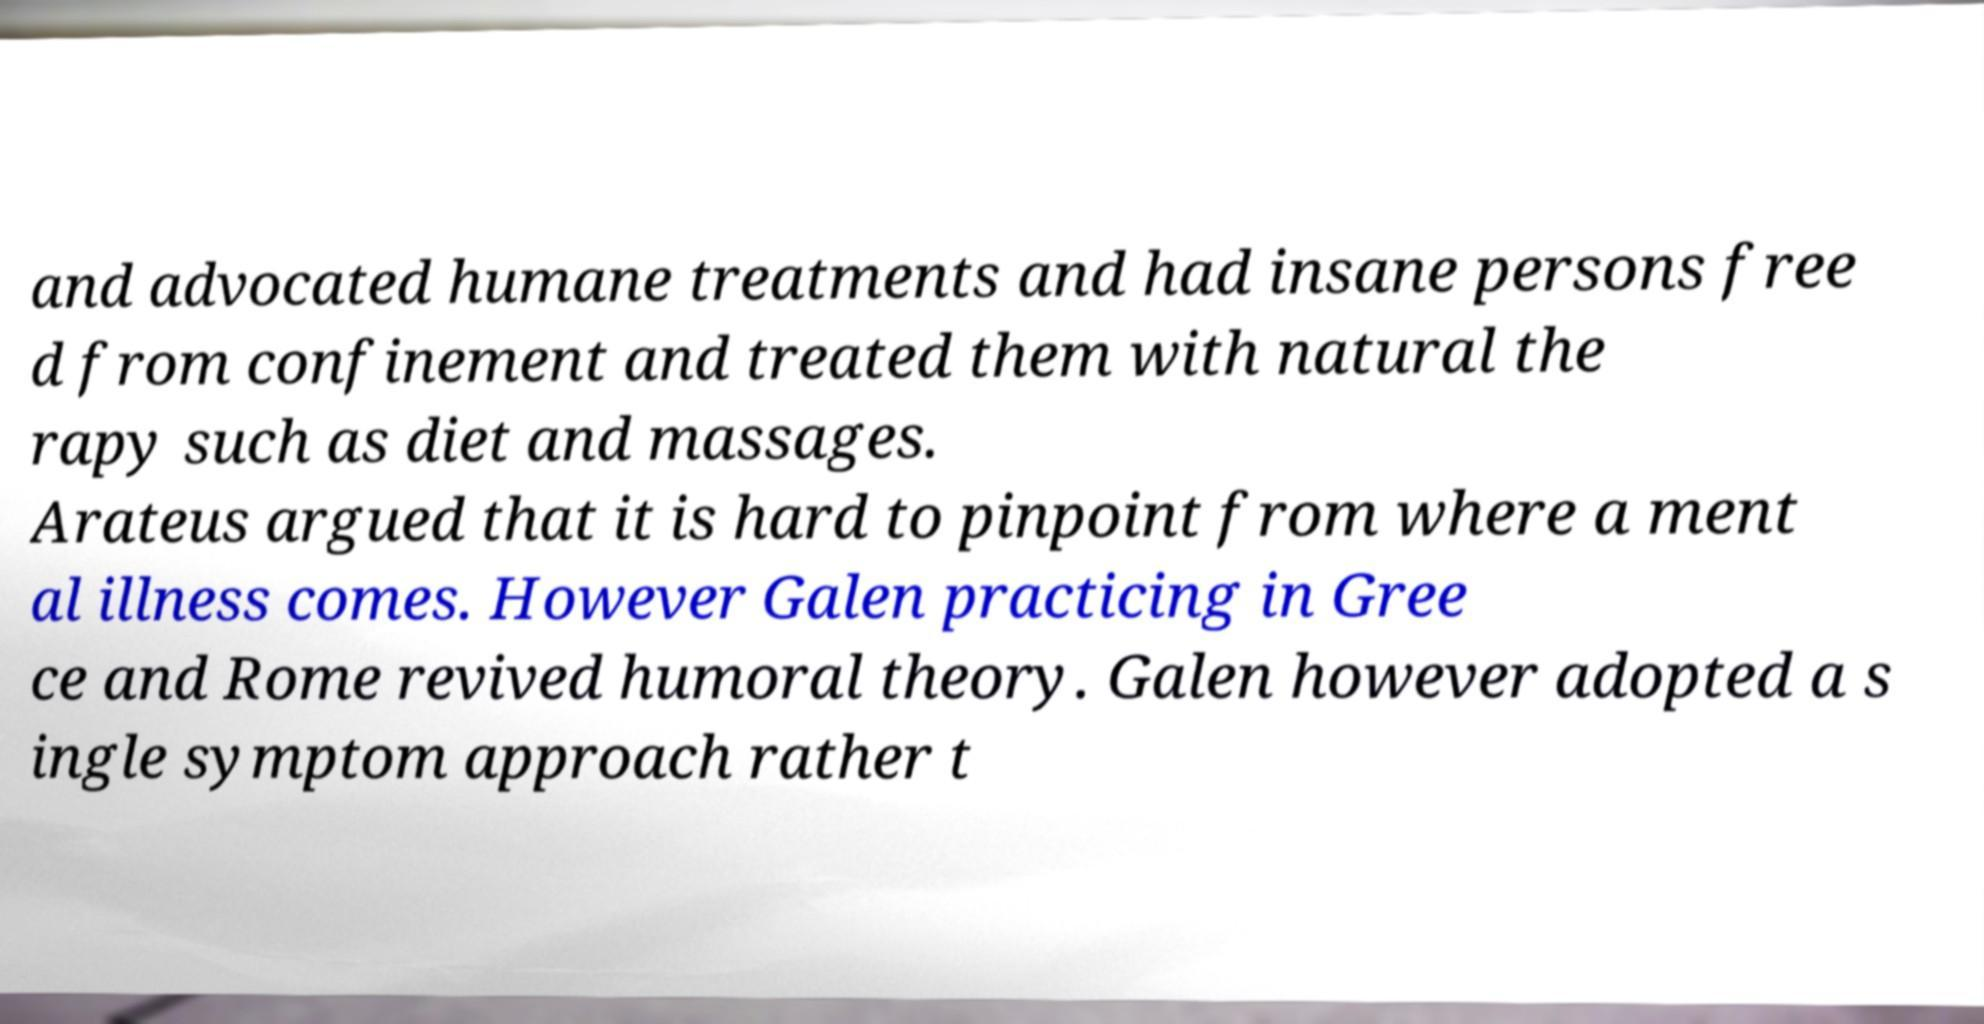Can you accurately transcribe the text from the provided image for me? and advocated humane treatments and had insane persons free d from confinement and treated them with natural the rapy such as diet and massages. Arateus argued that it is hard to pinpoint from where a ment al illness comes. However Galen practicing in Gree ce and Rome revived humoral theory. Galen however adopted a s ingle symptom approach rather t 